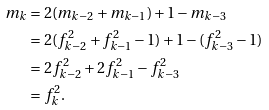Convert formula to latex. <formula><loc_0><loc_0><loc_500><loc_500>m _ { k } & = 2 ( m _ { k - 2 } + m _ { k - 1 } ) + 1 - m _ { k - 3 } \\ & = 2 ( f _ { k - 2 } ^ { 2 } + f _ { k - 1 } ^ { 2 } - 1 ) + 1 - ( f _ { k - 3 } ^ { 2 } - 1 ) \\ & = 2 f _ { k - 2 } ^ { 2 } + 2 f _ { k - 1 } ^ { 2 } - f _ { k - 3 } ^ { 2 } \\ & = f _ { k } ^ { 2 } .</formula> 